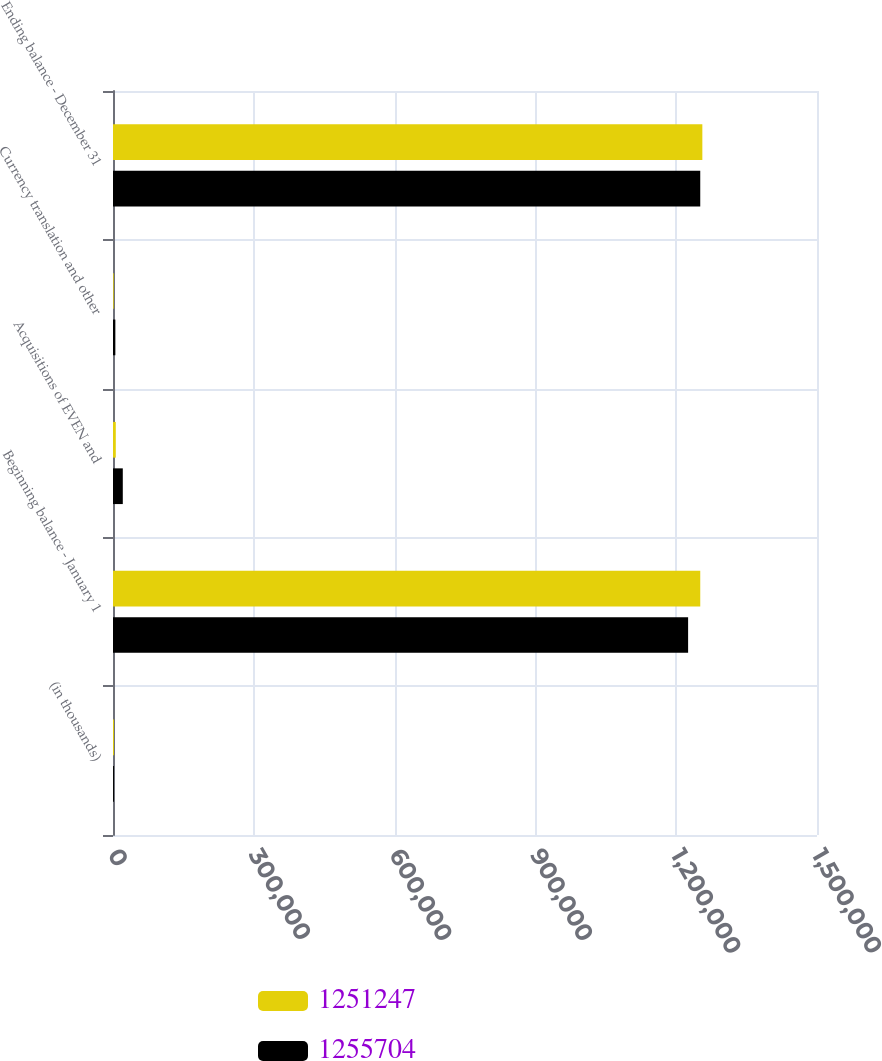Convert chart. <chart><loc_0><loc_0><loc_500><loc_500><stacked_bar_chart><ecel><fcel>(in thousands)<fcel>Beginning balance - January 1<fcel>Acquisitions of EVEN and<fcel>Currency translation and other<fcel>Ending balance - December 31<nl><fcel>1.25125e+06<fcel>2013<fcel>1.25125e+06<fcel>5936<fcel>1479<fcel>1.2557e+06<nl><fcel>1.2557e+06<fcel>2012<fcel>1.22538e+06<fcel>20866<fcel>5006<fcel>1.25125e+06<nl></chart> 